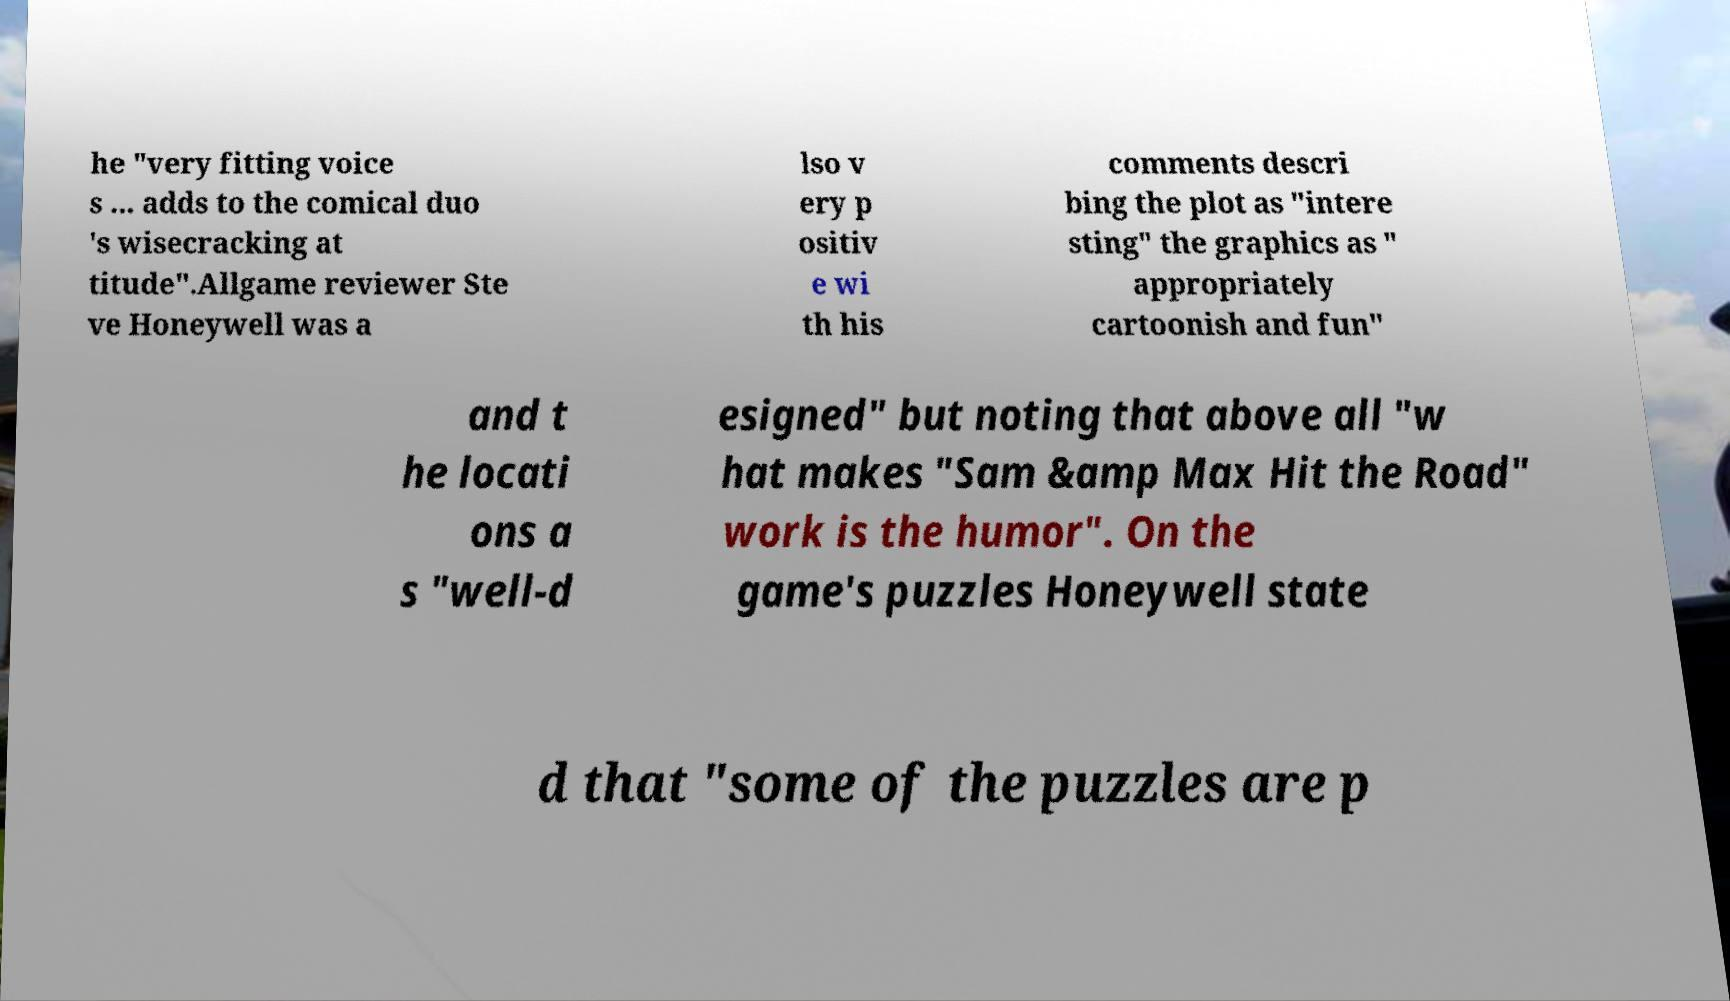Can you read and provide the text displayed in the image?This photo seems to have some interesting text. Can you extract and type it out for me? he "very fitting voice s ... adds to the comical duo 's wisecracking at titude".Allgame reviewer Ste ve Honeywell was a lso v ery p ositiv e wi th his comments descri bing the plot as "intere sting" the graphics as " appropriately cartoonish and fun" and t he locati ons a s "well-d esigned" but noting that above all "w hat makes "Sam &amp Max Hit the Road" work is the humor". On the game's puzzles Honeywell state d that "some of the puzzles are p 